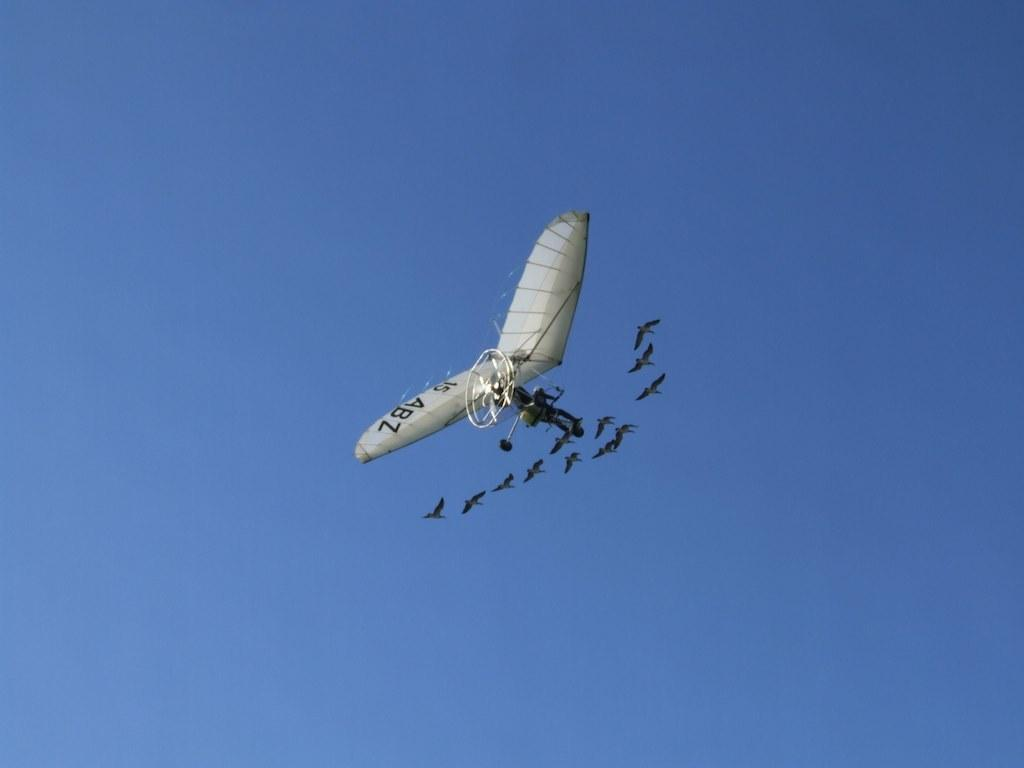<image>
Summarize the visual content of the image. A single person aircraft with ABZ on its wind is flying with a flock of birds. 